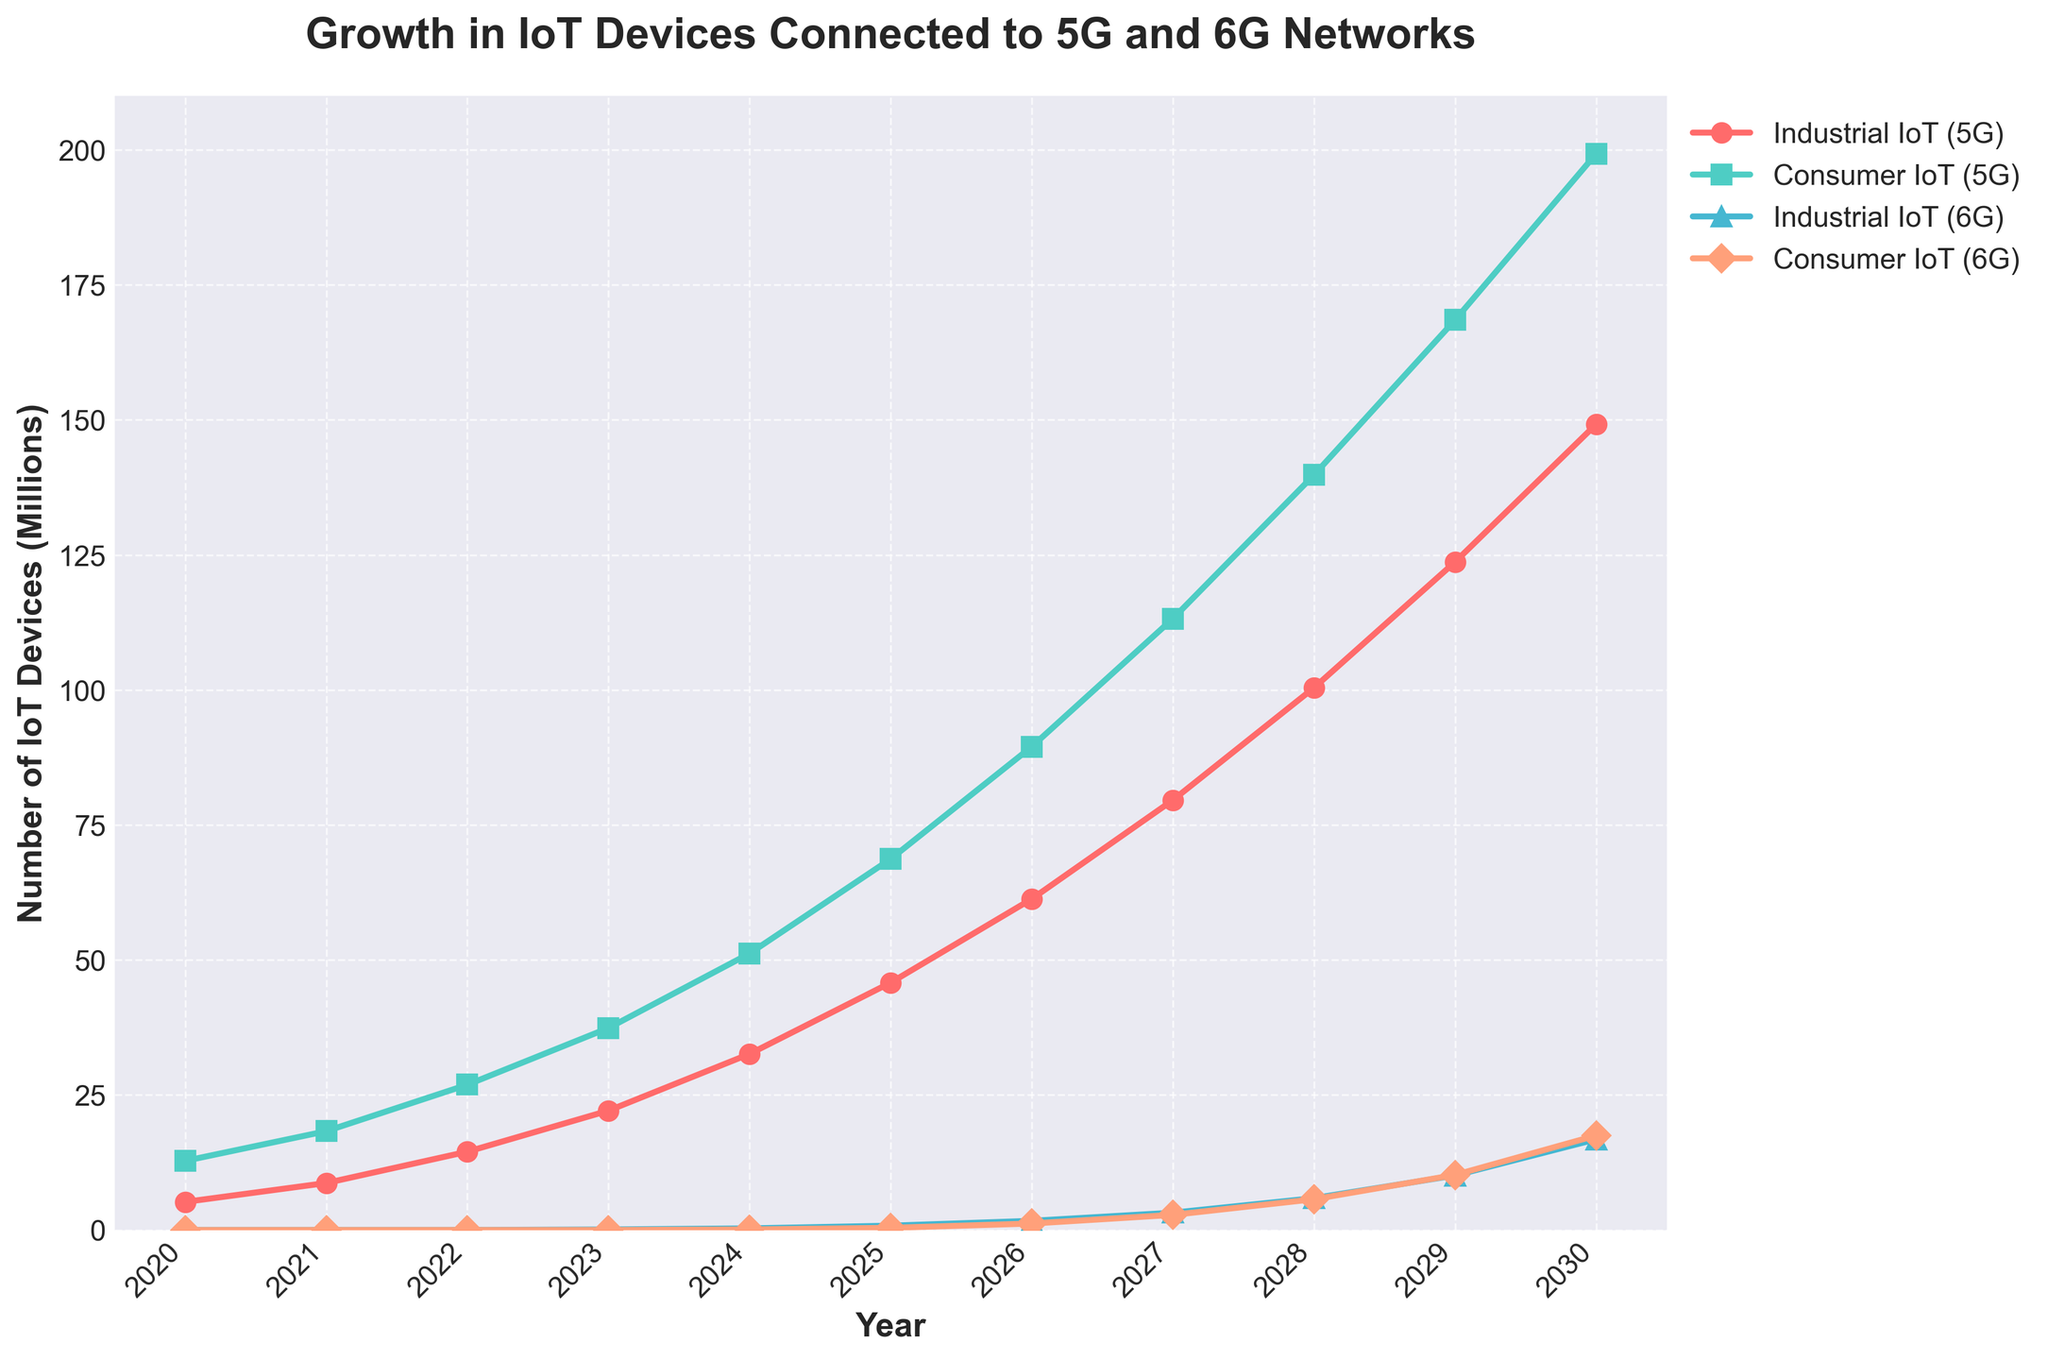What is the growth trend for industrial IoT devices connected to 5G from 2020 to 2030? The plot shows an increasing growth trend for industrial IoT devices connected to 5G, starting from around 5.2 million in 2020 and reaching approximately 149.2 million in 2030. The trend is consistently upward, indicating significant growth over these years.
Answer: Increasing Which year did industrial IoT devices surpass 50 million on 5G? By examining the plotted values, industrial IoT devices exceed 50 million in 2024, where the count is 51.2 million.
Answer: 2024 Compare the number of consumer IoT devices connected to 5G and 6G in 2028. In the year 2028, the plot shows around 139.8 million consumer IoT devices connected to 5G and approximately 5.7 million connected to 6G.
Answer: 139.8 million (5G) vs 5.7 million (6G) What is the difference in the number of industrial IoT devices connected to 5G and 6G in 2030? In 2030, the number of industrial IoT devices connected to 5G is approximately 149.2 million, and for 6G, it is about 16.8 million. The difference is 149.2 million minus 16.8 million.
Answer: 132.4 million Which segment shows a higher growth rate when transitioning from 2029 to 2030: consumer IoT on 5G or consumer IoT on 6G? The number of consumer IoT devices connected to 5G increases from 168.5 million in 2029 to 199.3 million in 2030, a difference of 30.8 million. For 6G, the count increases from 10.2 million to 17.5 million, a difference of 7.3 million. The higher growth is in consumer IoT devices on 5G.
Answer: Consumer IoT on 5G In which year does the number of consumer IoT devices connected to 6G surpass 10 million? According to the plot, consumer IoT devices connected to 6G surpass 10 million in 2029.
Answer: 2029 What can be said about the visual trend in industrial IoT devices connected to 6G from 2023 to 2030? The plot shows that industrial IoT devices connected to 6G begin with almost negligible numbers in 2023 and then show an exponential growth trend, increasing significantly year by year until 2030.
Answer: Exponential growth How many total IoT devices (consumer and industrial) are connected to both 5G and 6G in 2026? In 2026, the number of consumer IoT devices connected to 5G is 89.5 million, industrial IoT on 5G is 61.3 million, consumer IoT on 6G is 1.2 million, and industrial IoT on 6G is 1.7 million. Summing these gives 89.5 + 61.3 + 1.2 + 1.7.
Answer: 153.7 million 